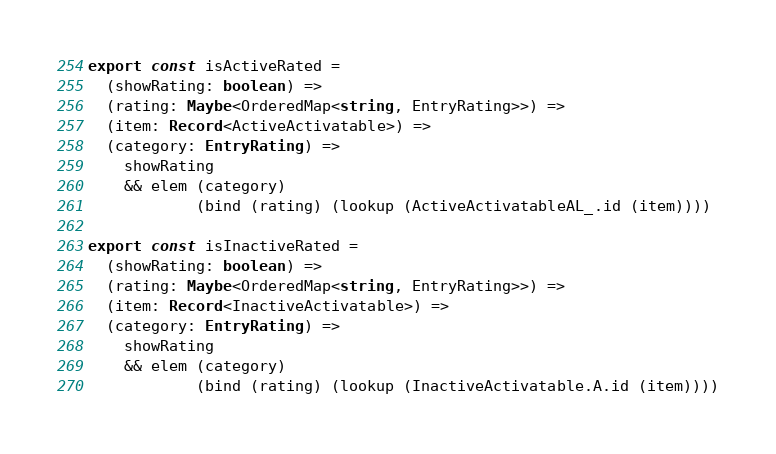<code> <loc_0><loc_0><loc_500><loc_500><_TypeScript_>export const isActiveRated =
  (showRating: boolean) =>
  (rating: Maybe<OrderedMap<string, EntryRating>>) =>
  (item: Record<ActiveActivatable>) =>
  (category: EntryRating) =>
    showRating
    && elem (category)
            (bind (rating) (lookup (ActiveActivatableAL_.id (item))))

export const isInactiveRated =
  (showRating: boolean) =>
  (rating: Maybe<OrderedMap<string, EntryRating>>) =>
  (item: Record<InactiveActivatable>) =>
  (category: EntryRating) =>
    showRating
    && elem (category)
            (bind (rating) (lookup (InactiveActivatable.A.id (item))))
</code> 